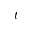Convert formula to latex. <formula><loc_0><loc_0><loc_500><loc_500>t</formula> 